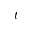Convert formula to latex. <formula><loc_0><loc_0><loc_500><loc_500>t</formula> 